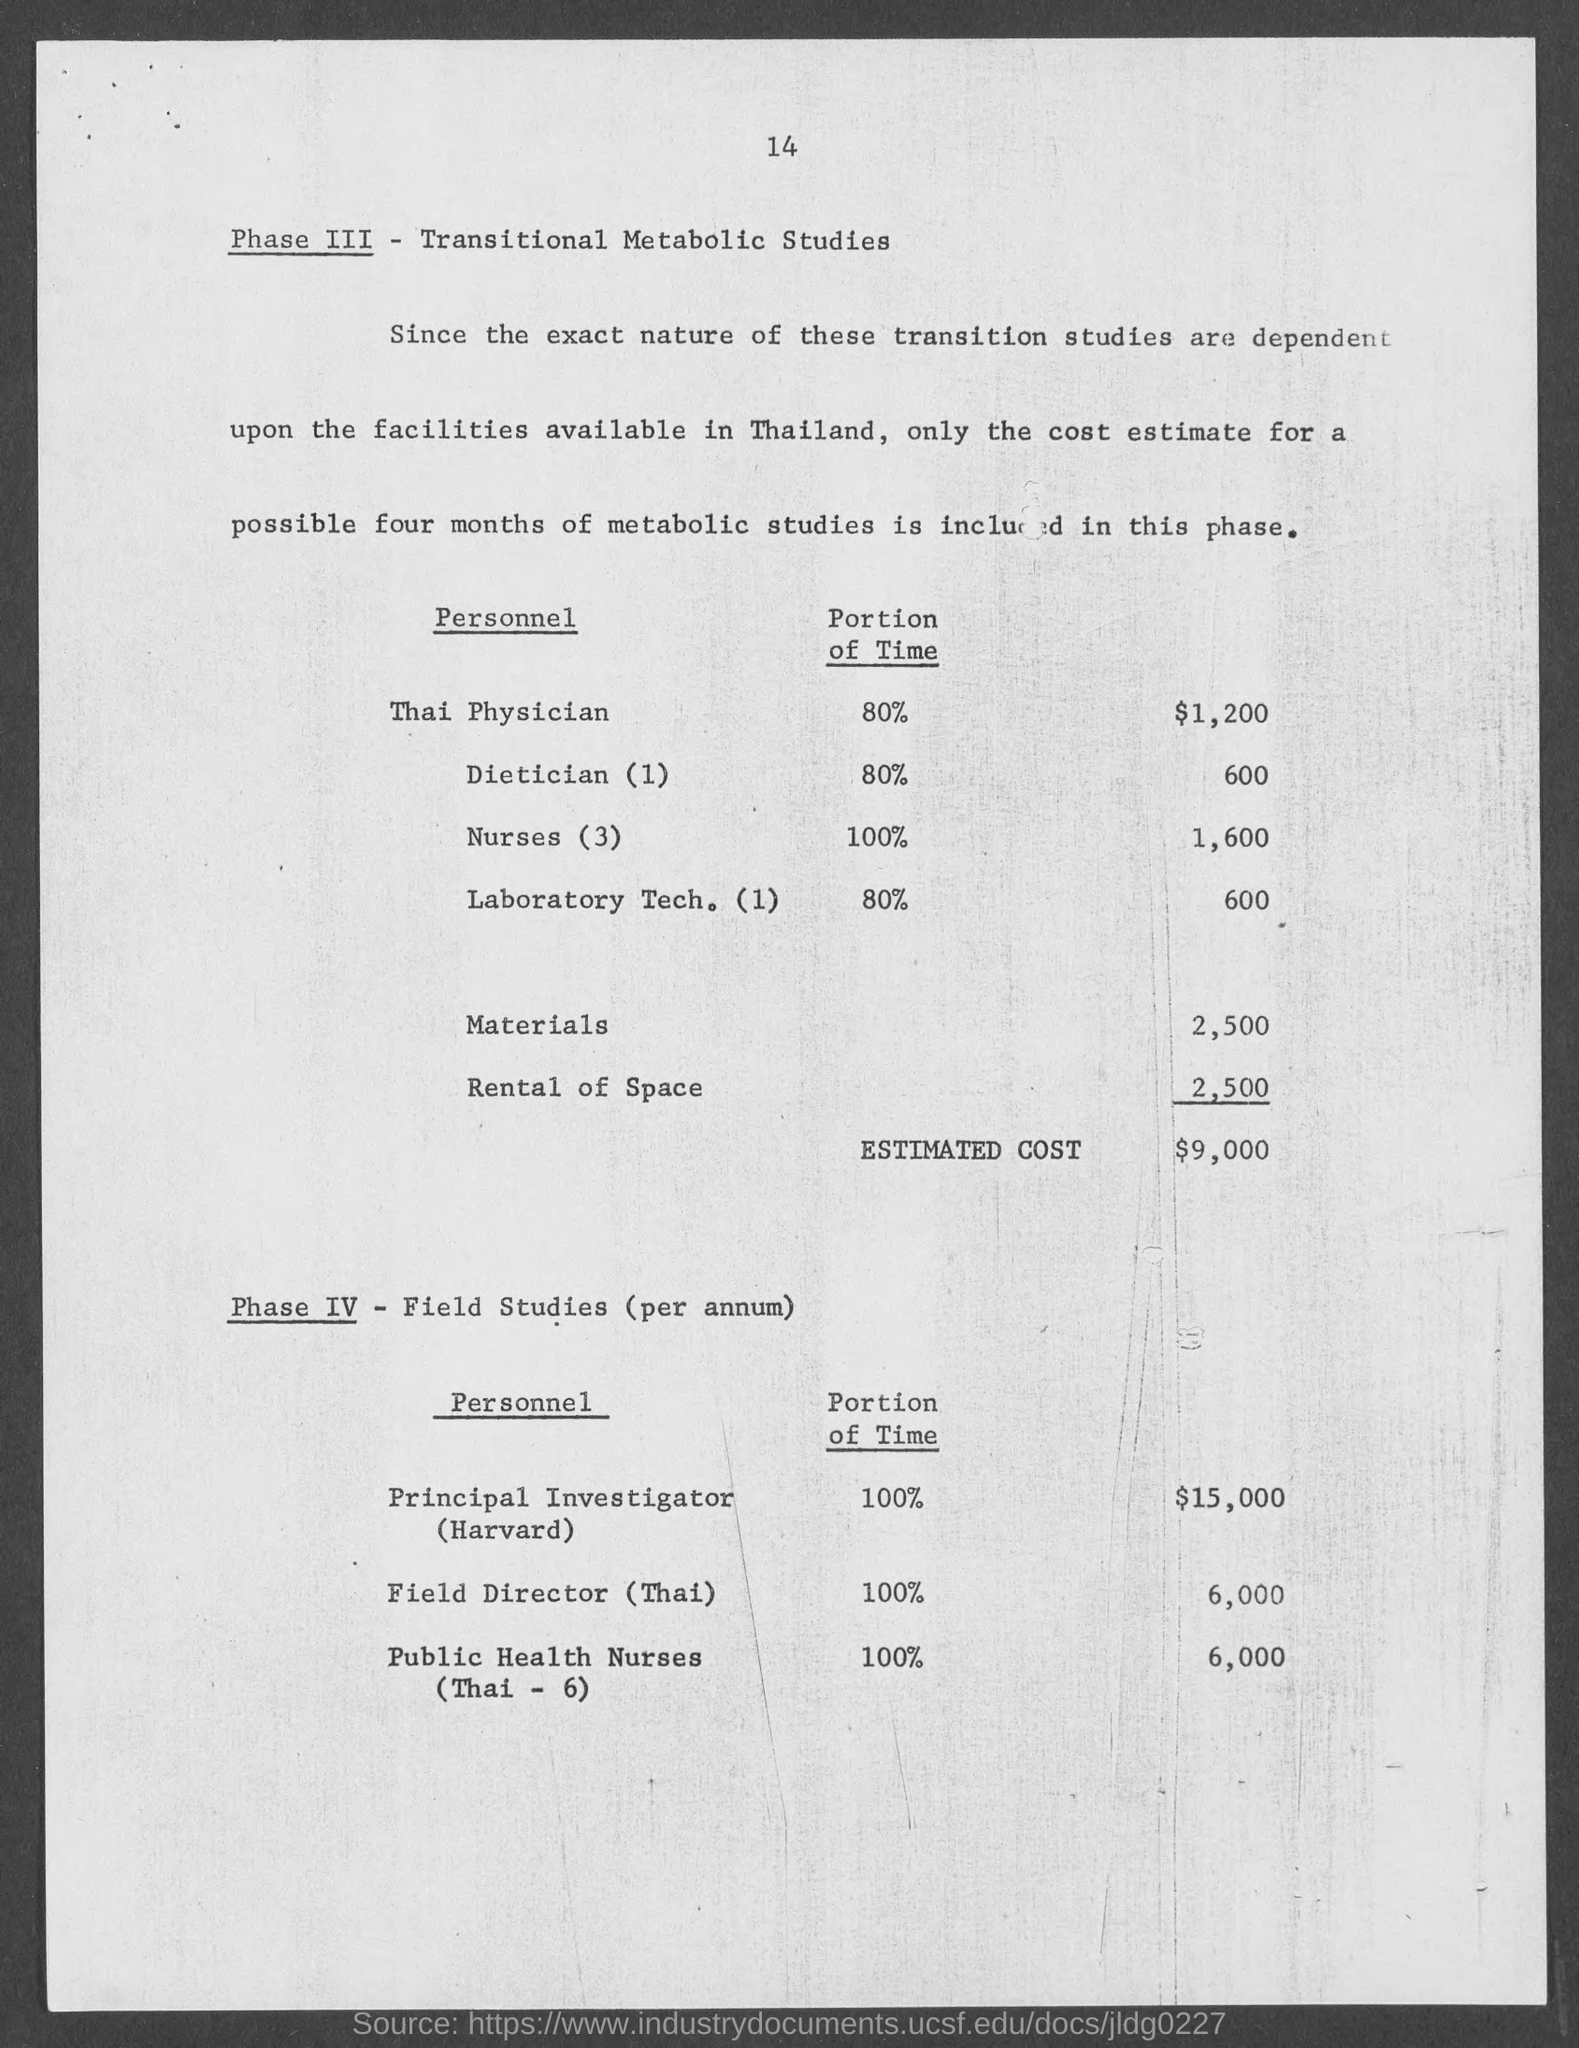Outline some significant characteristics in this image. The cost estimate for the Principal Investigator (Harvard) as mentioned in the document is $15,000. The principal investigator has dedicated 100% of their time to the project, as stated in the relevant document. The cost estimate for a Thai physician, as specified in the document, is $1,200. According to the document, 80% of the Thai physician's time is dedicated to a specific task or activity. 